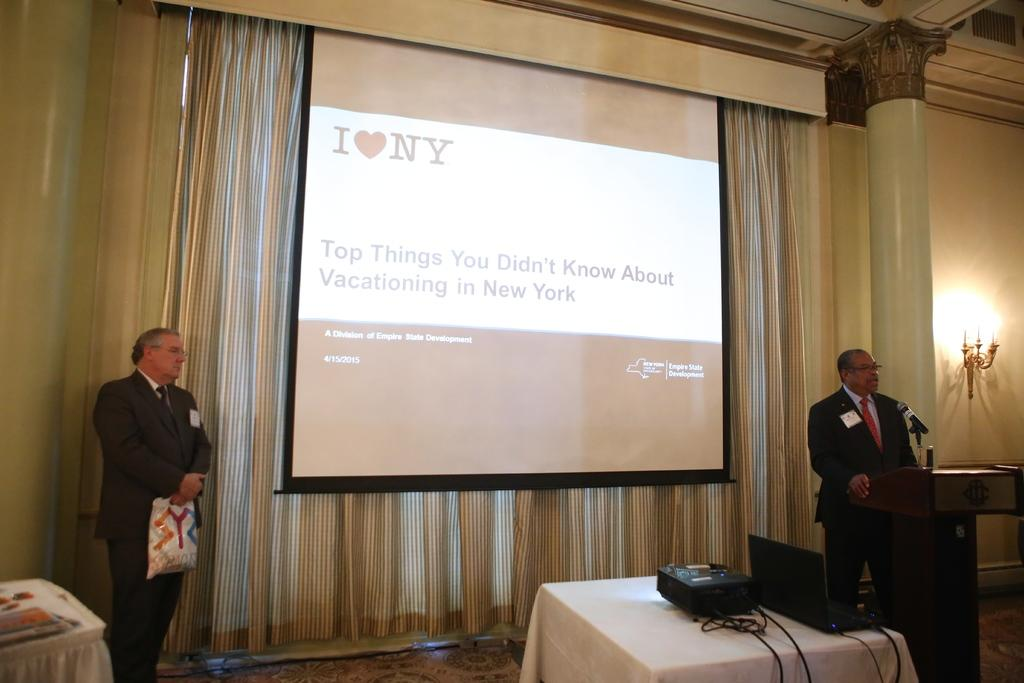How many people are in the image? There are two persons in the image. What are the persons doing in the image? The persons are standing on the floor. Can you describe any other objects or furniture in the image? There is an unspecified object and a table in the image. Are the persons wearing masks in the image? There is no mention of masks in the image, so we cannot determine if the persons are wearing them. Can you describe the type of party taking place in the image? There is no indication of a party in the image, so we cannot describe the type of party. 